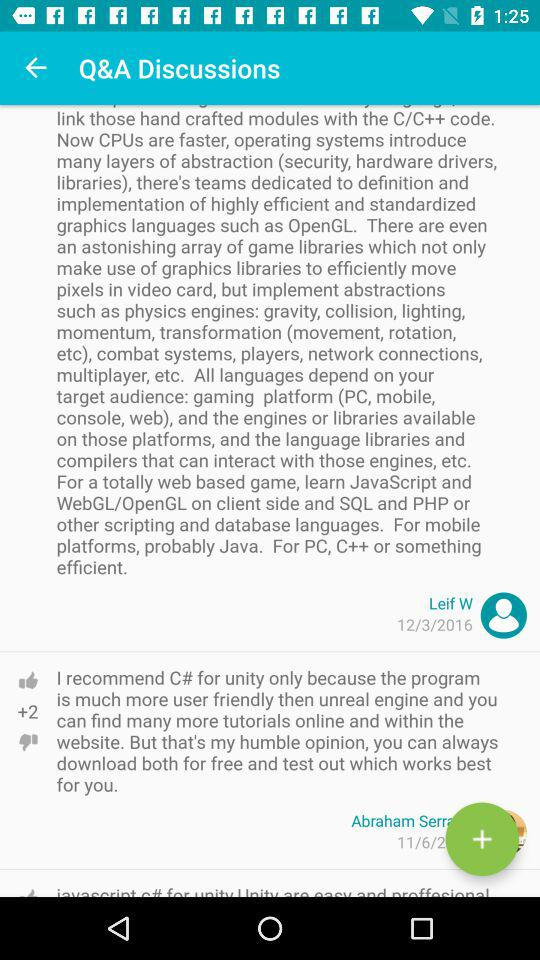When was Leif W posting the comment? Leif W posted the comment on March 12, 2016. 